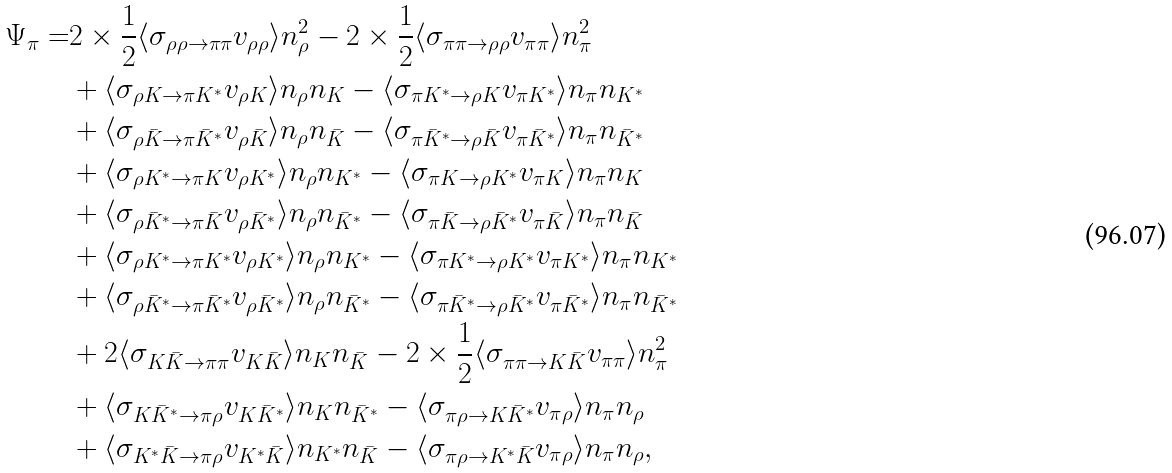Convert formula to latex. <formula><loc_0><loc_0><loc_500><loc_500>\Psi _ { \pi } = & 2 \times \frac { 1 } { 2 } \langle \sigma _ { \rho \rho \rightarrow \pi \pi } v _ { \rho \rho } \rangle n _ { \rho } ^ { 2 } - 2 \times \frac { 1 } { 2 } \langle \sigma _ { \pi \pi \rightarrow \rho \rho } v _ { \pi \pi } \rangle n _ { \pi } ^ { 2 } \\ & + \langle \sigma _ { \rho K \rightarrow \pi K ^ { \ast } } v _ { \rho K } \rangle n _ { \rho } n _ { K } - \langle \sigma _ { \pi K ^ { \ast } \rightarrow \rho K } v _ { \pi K ^ { \ast } } \rangle n _ { \pi } n _ { K ^ { \ast } } \\ & + \langle \sigma _ { \rho \bar { K } \rightarrow \pi \bar { K } ^ { \ast } } v _ { \rho \bar { K } } \rangle n _ { \rho } n _ { \bar { K } } - \langle \sigma _ { \pi \bar { K } ^ { \ast } \rightarrow \rho \bar { K } } v _ { \pi \bar { K } ^ { \ast } } \rangle n _ { \pi } n _ { \bar { K } ^ { \ast } } \\ & + \langle \sigma _ { \rho K ^ { \ast } \rightarrow \pi K } v _ { \rho { K } ^ { \ast } } \rangle n _ { \rho } n _ { K ^ { \ast } } - \langle \sigma _ { \pi K \rightarrow \rho K ^ { \ast } } v _ { \pi K } \rangle n _ { \pi } n _ { K } \\ & + \langle \sigma _ { \rho \bar { K } ^ { \ast } \rightarrow \pi \bar { K } } v _ { \rho \bar { K } ^ { \ast } } \rangle n _ { \rho } n _ { \bar { K } ^ { \ast } } - \langle \sigma _ { \pi \bar { K } \rightarrow \rho \bar { K } ^ { \ast } } v _ { \pi \bar { K } } \rangle n _ { \pi } n _ { \bar { K } } \\ & + \langle \sigma _ { \rho K ^ { \ast } \rightarrow \pi K ^ { \ast } } v _ { \rho K ^ { \ast } } \rangle n _ { \rho } n _ { K ^ { \ast } } - \langle \sigma _ { \pi K ^ { \ast } \rightarrow \rho K ^ { \ast } } v _ { \pi K ^ { \ast } } \rangle n _ { \pi } n _ { K ^ { \ast } } \\ & + \langle \sigma _ { \rho \bar { K } ^ { \ast } \rightarrow \pi \bar { K } ^ { \ast } } v _ { \rho \bar { K } ^ { \ast } } \rangle n _ { \rho } n _ { \bar { K } ^ { \ast } } - \langle \sigma _ { \pi \bar { K } ^ { \ast } \rightarrow \rho \bar { K } ^ { \ast } } v _ { \pi \bar { K } ^ { \ast } } \rangle n _ { \pi } n _ { \bar { K } ^ { \ast } } \\ & + 2 \langle \sigma _ { K \bar { K } \rightarrow \pi \pi } v _ { K \bar { K } } \rangle n _ { K } n _ { \bar { K } } - 2 \times \frac { 1 } { 2 } \langle \sigma _ { \pi \pi \rightarrow K \bar { K } } v _ { \pi \pi } \rangle n _ { \pi } ^ { 2 } \\ & + \langle \sigma _ { K \bar { K } ^ { \ast } \rightarrow \pi \rho } v _ { K \bar { K } ^ { \ast } } \rangle n _ { K } n _ { \bar { K } ^ { \ast } } - \langle \sigma _ { \pi \rho \rightarrow K \bar { K } ^ { \ast } } v _ { \pi \rho } \rangle n _ { \pi } n _ { \rho } \\ & + \langle \sigma _ { K ^ { \ast } \bar { K } \rightarrow \pi \rho } v _ { K ^ { \ast } \bar { K } } \rangle n _ { K ^ { \ast } } n _ { \bar { K } } - \langle \sigma _ { \pi \rho \rightarrow K ^ { \ast } \bar { K } } v _ { \pi \rho } \rangle n _ { \pi } n _ { \rho } ,</formula> 